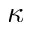<formula> <loc_0><loc_0><loc_500><loc_500>\kappa</formula> 